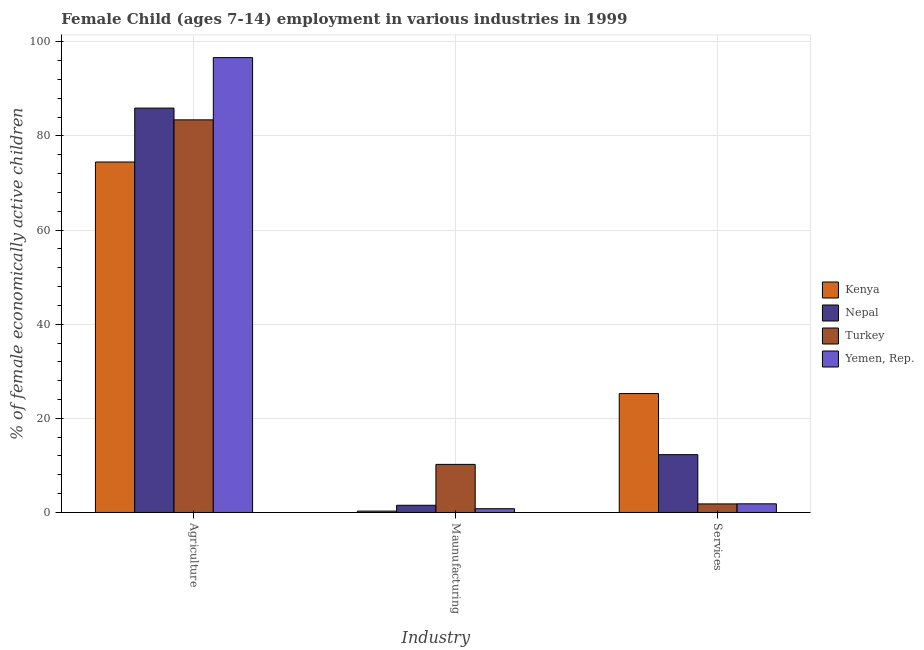How many different coloured bars are there?
Your answer should be compact. 4. How many groups of bars are there?
Make the answer very short. 3. Are the number of bars per tick equal to the number of legend labels?
Provide a short and direct response. Yes. How many bars are there on the 1st tick from the left?
Your answer should be very brief. 4. How many bars are there on the 2nd tick from the right?
Offer a very short reply. 4. What is the label of the 2nd group of bars from the left?
Your answer should be compact. Maunufacturing. What is the percentage of economically active children in manufacturing in Kenya?
Offer a very short reply. 0.29. Across all countries, what is the maximum percentage of economically active children in services?
Your response must be concise. 25.26. Across all countries, what is the minimum percentage of economically active children in manufacturing?
Your response must be concise. 0.29. In which country was the percentage of economically active children in agriculture maximum?
Ensure brevity in your answer.  Yemen, Rep. In which country was the percentage of economically active children in manufacturing minimum?
Ensure brevity in your answer.  Kenya. What is the total percentage of economically active children in services in the graph?
Ensure brevity in your answer.  41.2. What is the difference between the percentage of economically active children in agriculture in Nepal and that in Yemen, Rep.?
Offer a terse response. -10.72. What is the difference between the percentage of economically active children in services in Turkey and the percentage of economically active children in manufacturing in Nepal?
Keep it short and to the point. 0.29. What is the average percentage of economically active children in services per country?
Give a very brief answer. 10.3. What is the difference between the percentage of economically active children in services and percentage of economically active children in manufacturing in Nepal?
Your response must be concise. 10.75. What is the ratio of the percentage of economically active children in manufacturing in Nepal to that in Kenya?
Make the answer very short. 5.23. Is the percentage of economically active children in services in Turkey less than that in Yemen, Rep.?
Make the answer very short. Yes. What is the difference between the highest and the second highest percentage of economically active children in agriculture?
Ensure brevity in your answer.  10.72. What is the difference between the highest and the lowest percentage of economically active children in manufacturing?
Offer a very short reply. 9.92. What does the 2nd bar from the right in Services represents?
Give a very brief answer. Turkey. Is it the case that in every country, the sum of the percentage of economically active children in agriculture and percentage of economically active children in manufacturing is greater than the percentage of economically active children in services?
Provide a succinct answer. Yes. Are all the bars in the graph horizontal?
Ensure brevity in your answer.  No. How many countries are there in the graph?
Make the answer very short. 4. Are the values on the major ticks of Y-axis written in scientific E-notation?
Your answer should be very brief. No. What is the title of the graph?
Ensure brevity in your answer.  Female Child (ages 7-14) employment in various industries in 1999. What is the label or title of the X-axis?
Your answer should be very brief. Industry. What is the label or title of the Y-axis?
Your answer should be very brief. % of female economically active children. What is the % of female economically active children of Kenya in Agriculture?
Provide a succinct answer. 74.45. What is the % of female economically active children in Nepal in Agriculture?
Provide a succinct answer. 85.9. What is the % of female economically active children in Turkey in Agriculture?
Keep it short and to the point. 83.4. What is the % of female economically active children of Yemen, Rep. in Agriculture?
Offer a terse response. 96.62. What is the % of female economically active children in Kenya in Maunufacturing?
Keep it short and to the point. 0.29. What is the % of female economically active children in Nepal in Maunufacturing?
Give a very brief answer. 1.53. What is the % of female economically active children in Turkey in Maunufacturing?
Your answer should be compact. 10.22. What is the % of female economically active children of Yemen, Rep. in Maunufacturing?
Offer a terse response. 0.8. What is the % of female economically active children in Kenya in Services?
Provide a short and direct response. 25.26. What is the % of female economically active children of Nepal in Services?
Your answer should be very brief. 12.28. What is the % of female economically active children in Turkey in Services?
Your answer should be compact. 1.82. What is the % of female economically active children in Yemen, Rep. in Services?
Provide a short and direct response. 1.84. Across all Industry, what is the maximum % of female economically active children of Kenya?
Provide a succinct answer. 74.45. Across all Industry, what is the maximum % of female economically active children in Nepal?
Make the answer very short. 85.9. Across all Industry, what is the maximum % of female economically active children of Turkey?
Keep it short and to the point. 83.4. Across all Industry, what is the maximum % of female economically active children of Yemen, Rep.?
Ensure brevity in your answer.  96.62. Across all Industry, what is the minimum % of female economically active children in Kenya?
Offer a terse response. 0.29. Across all Industry, what is the minimum % of female economically active children in Nepal?
Offer a terse response. 1.53. Across all Industry, what is the minimum % of female economically active children of Turkey?
Your answer should be very brief. 1.82. What is the total % of female economically active children of Kenya in the graph?
Ensure brevity in your answer.  100. What is the total % of female economically active children in Nepal in the graph?
Keep it short and to the point. 99.71. What is the total % of female economically active children of Turkey in the graph?
Offer a very short reply. 95.44. What is the total % of female economically active children in Yemen, Rep. in the graph?
Your response must be concise. 99.26. What is the difference between the % of female economically active children of Kenya in Agriculture and that in Maunufacturing?
Provide a short and direct response. 74.15. What is the difference between the % of female economically active children of Nepal in Agriculture and that in Maunufacturing?
Ensure brevity in your answer.  84.37. What is the difference between the % of female economically active children in Turkey in Agriculture and that in Maunufacturing?
Provide a succinct answer. 73.18. What is the difference between the % of female economically active children of Yemen, Rep. in Agriculture and that in Maunufacturing?
Give a very brief answer. 95.82. What is the difference between the % of female economically active children in Kenya in Agriculture and that in Services?
Provide a succinct answer. 49.19. What is the difference between the % of female economically active children in Nepal in Agriculture and that in Services?
Offer a terse response. 73.62. What is the difference between the % of female economically active children of Turkey in Agriculture and that in Services?
Offer a terse response. 81.58. What is the difference between the % of female economically active children in Yemen, Rep. in Agriculture and that in Services?
Your answer should be compact. 94.78. What is the difference between the % of female economically active children of Kenya in Maunufacturing and that in Services?
Your answer should be compact. -24.97. What is the difference between the % of female economically active children of Nepal in Maunufacturing and that in Services?
Make the answer very short. -10.75. What is the difference between the % of female economically active children of Turkey in Maunufacturing and that in Services?
Provide a short and direct response. 8.39. What is the difference between the % of female economically active children of Yemen, Rep. in Maunufacturing and that in Services?
Provide a succinct answer. -1.04. What is the difference between the % of female economically active children in Kenya in Agriculture and the % of female economically active children in Nepal in Maunufacturing?
Offer a very short reply. 72.91. What is the difference between the % of female economically active children in Kenya in Agriculture and the % of female economically active children in Turkey in Maunufacturing?
Ensure brevity in your answer.  64.23. What is the difference between the % of female economically active children of Kenya in Agriculture and the % of female economically active children of Yemen, Rep. in Maunufacturing?
Provide a short and direct response. 73.65. What is the difference between the % of female economically active children of Nepal in Agriculture and the % of female economically active children of Turkey in Maunufacturing?
Your answer should be very brief. 75.68. What is the difference between the % of female economically active children of Nepal in Agriculture and the % of female economically active children of Yemen, Rep. in Maunufacturing?
Provide a succinct answer. 85.1. What is the difference between the % of female economically active children of Turkey in Agriculture and the % of female economically active children of Yemen, Rep. in Maunufacturing?
Provide a succinct answer. 82.6. What is the difference between the % of female economically active children in Kenya in Agriculture and the % of female economically active children in Nepal in Services?
Make the answer very short. 62.17. What is the difference between the % of female economically active children in Kenya in Agriculture and the % of female economically active children in Turkey in Services?
Ensure brevity in your answer.  72.62. What is the difference between the % of female economically active children of Kenya in Agriculture and the % of female economically active children of Yemen, Rep. in Services?
Provide a succinct answer. 72.61. What is the difference between the % of female economically active children of Nepal in Agriculture and the % of female economically active children of Turkey in Services?
Offer a terse response. 84.08. What is the difference between the % of female economically active children in Nepal in Agriculture and the % of female economically active children in Yemen, Rep. in Services?
Give a very brief answer. 84.06. What is the difference between the % of female economically active children of Turkey in Agriculture and the % of female economically active children of Yemen, Rep. in Services?
Offer a terse response. 81.56. What is the difference between the % of female economically active children of Kenya in Maunufacturing and the % of female economically active children of Nepal in Services?
Provide a short and direct response. -11.99. What is the difference between the % of female economically active children in Kenya in Maunufacturing and the % of female economically active children in Turkey in Services?
Ensure brevity in your answer.  -1.53. What is the difference between the % of female economically active children in Kenya in Maunufacturing and the % of female economically active children in Yemen, Rep. in Services?
Offer a very short reply. -1.55. What is the difference between the % of female economically active children in Nepal in Maunufacturing and the % of female economically active children in Turkey in Services?
Offer a terse response. -0.29. What is the difference between the % of female economically active children in Nepal in Maunufacturing and the % of female economically active children in Yemen, Rep. in Services?
Your answer should be very brief. -0.31. What is the difference between the % of female economically active children of Turkey in Maunufacturing and the % of female economically active children of Yemen, Rep. in Services?
Provide a succinct answer. 8.38. What is the average % of female economically active children of Kenya per Industry?
Make the answer very short. 33.33. What is the average % of female economically active children of Nepal per Industry?
Offer a very short reply. 33.24. What is the average % of female economically active children of Turkey per Industry?
Ensure brevity in your answer.  31.81. What is the average % of female economically active children in Yemen, Rep. per Industry?
Keep it short and to the point. 33.09. What is the difference between the % of female economically active children of Kenya and % of female economically active children of Nepal in Agriculture?
Provide a short and direct response. -11.45. What is the difference between the % of female economically active children in Kenya and % of female economically active children in Turkey in Agriculture?
Ensure brevity in your answer.  -8.95. What is the difference between the % of female economically active children of Kenya and % of female economically active children of Yemen, Rep. in Agriculture?
Offer a terse response. -22.17. What is the difference between the % of female economically active children in Nepal and % of female economically active children in Turkey in Agriculture?
Provide a short and direct response. 2.5. What is the difference between the % of female economically active children of Nepal and % of female economically active children of Yemen, Rep. in Agriculture?
Offer a terse response. -10.72. What is the difference between the % of female economically active children in Turkey and % of female economically active children in Yemen, Rep. in Agriculture?
Offer a terse response. -13.22. What is the difference between the % of female economically active children in Kenya and % of female economically active children in Nepal in Maunufacturing?
Give a very brief answer. -1.24. What is the difference between the % of female economically active children in Kenya and % of female economically active children in Turkey in Maunufacturing?
Offer a terse response. -9.92. What is the difference between the % of female economically active children of Kenya and % of female economically active children of Yemen, Rep. in Maunufacturing?
Ensure brevity in your answer.  -0.51. What is the difference between the % of female economically active children in Nepal and % of female economically active children in Turkey in Maunufacturing?
Provide a succinct answer. -8.68. What is the difference between the % of female economically active children in Nepal and % of female economically active children in Yemen, Rep. in Maunufacturing?
Provide a succinct answer. 0.73. What is the difference between the % of female economically active children of Turkey and % of female economically active children of Yemen, Rep. in Maunufacturing?
Your answer should be compact. 9.42. What is the difference between the % of female economically active children of Kenya and % of female economically active children of Nepal in Services?
Keep it short and to the point. 12.98. What is the difference between the % of female economically active children of Kenya and % of female economically active children of Turkey in Services?
Offer a very short reply. 23.44. What is the difference between the % of female economically active children in Kenya and % of female economically active children in Yemen, Rep. in Services?
Give a very brief answer. 23.42. What is the difference between the % of female economically active children of Nepal and % of female economically active children of Turkey in Services?
Your answer should be very brief. 10.46. What is the difference between the % of female economically active children of Nepal and % of female economically active children of Yemen, Rep. in Services?
Make the answer very short. 10.44. What is the difference between the % of female economically active children in Turkey and % of female economically active children in Yemen, Rep. in Services?
Give a very brief answer. -0.02. What is the ratio of the % of female economically active children of Kenya in Agriculture to that in Maunufacturing?
Offer a very short reply. 253.97. What is the ratio of the % of female economically active children in Nepal in Agriculture to that in Maunufacturing?
Provide a succinct answer. 56.08. What is the ratio of the % of female economically active children of Turkey in Agriculture to that in Maunufacturing?
Provide a succinct answer. 8.16. What is the ratio of the % of female economically active children of Yemen, Rep. in Agriculture to that in Maunufacturing?
Your answer should be very brief. 120.78. What is the ratio of the % of female economically active children in Kenya in Agriculture to that in Services?
Ensure brevity in your answer.  2.95. What is the ratio of the % of female economically active children in Nepal in Agriculture to that in Services?
Offer a terse response. 7. What is the ratio of the % of female economically active children in Turkey in Agriculture to that in Services?
Give a very brief answer. 45.79. What is the ratio of the % of female economically active children of Yemen, Rep. in Agriculture to that in Services?
Offer a terse response. 52.51. What is the ratio of the % of female economically active children in Kenya in Maunufacturing to that in Services?
Offer a terse response. 0.01. What is the ratio of the % of female economically active children of Nepal in Maunufacturing to that in Services?
Offer a very short reply. 0.12. What is the ratio of the % of female economically active children of Turkey in Maunufacturing to that in Services?
Give a very brief answer. 5.61. What is the ratio of the % of female economically active children in Yemen, Rep. in Maunufacturing to that in Services?
Your response must be concise. 0.43. What is the difference between the highest and the second highest % of female economically active children of Kenya?
Your answer should be very brief. 49.19. What is the difference between the highest and the second highest % of female economically active children in Nepal?
Provide a short and direct response. 73.62. What is the difference between the highest and the second highest % of female economically active children of Turkey?
Keep it short and to the point. 73.18. What is the difference between the highest and the second highest % of female economically active children in Yemen, Rep.?
Make the answer very short. 94.78. What is the difference between the highest and the lowest % of female economically active children of Kenya?
Make the answer very short. 74.15. What is the difference between the highest and the lowest % of female economically active children in Nepal?
Provide a short and direct response. 84.37. What is the difference between the highest and the lowest % of female economically active children in Turkey?
Your response must be concise. 81.58. What is the difference between the highest and the lowest % of female economically active children in Yemen, Rep.?
Keep it short and to the point. 95.82. 